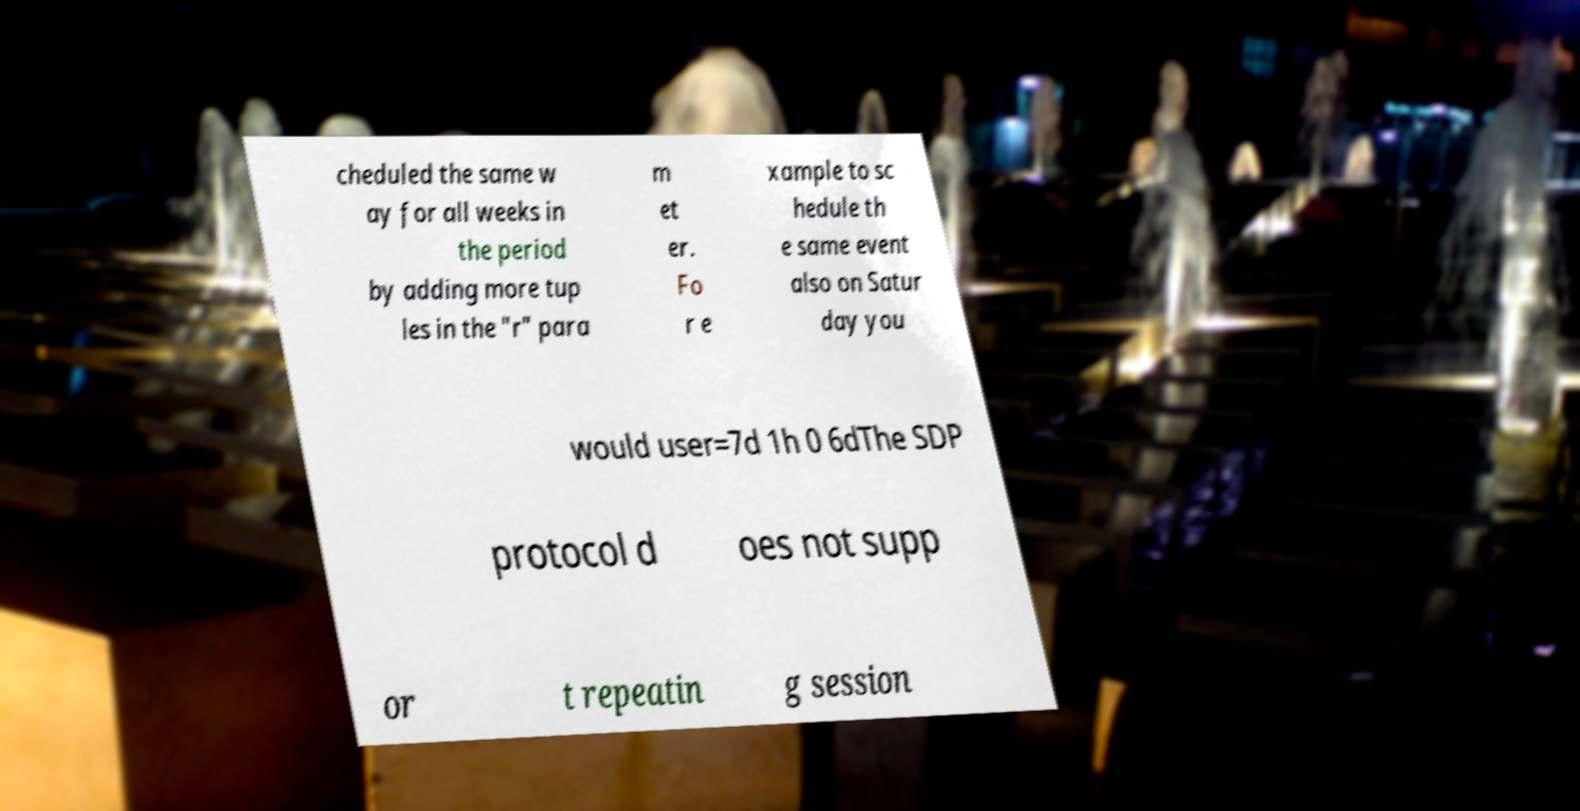Can you accurately transcribe the text from the provided image for me? cheduled the same w ay for all weeks in the period by adding more tup les in the "r" para m et er. Fo r e xample to sc hedule th e same event also on Satur day you would user=7d 1h 0 6dThe SDP protocol d oes not supp or t repeatin g session 